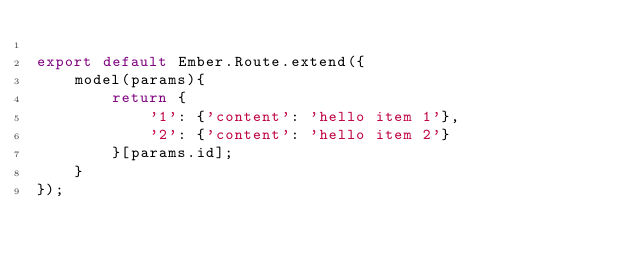<code> <loc_0><loc_0><loc_500><loc_500><_JavaScript_>
export default Ember.Route.extend({
    model(params){
        return {
            '1': {'content': 'hello item 1'},
            '2': {'content': 'hello item 2'}
        }[params.id];
    }
});</code> 